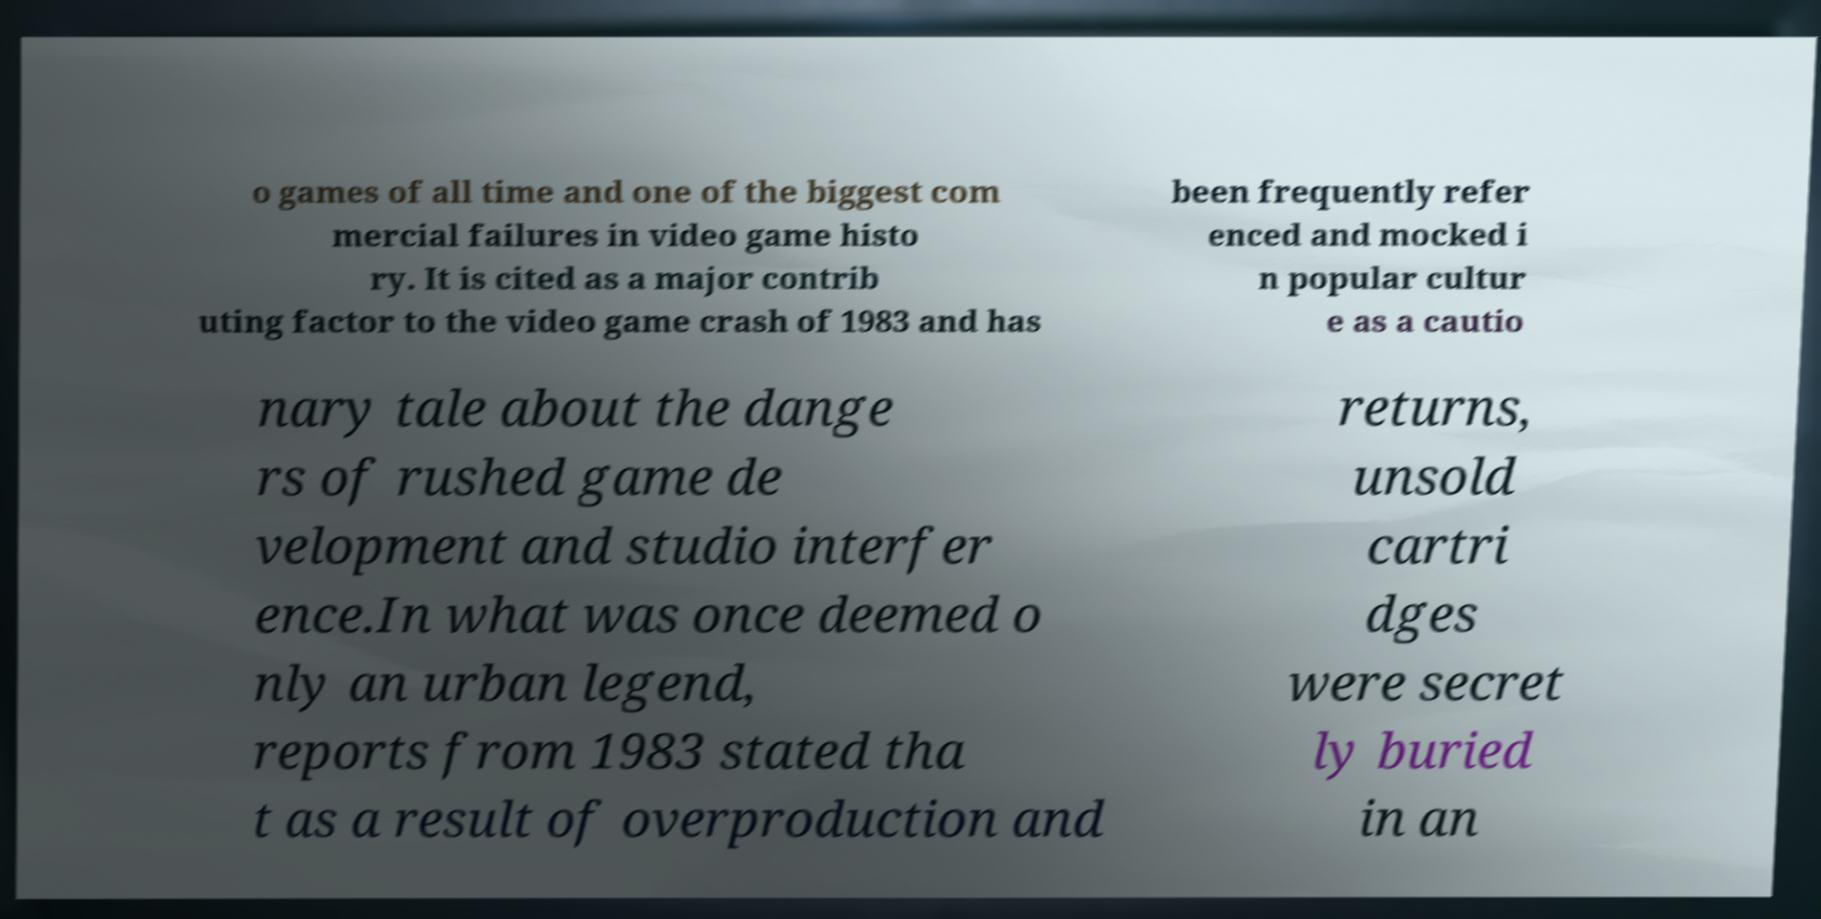There's text embedded in this image that I need extracted. Can you transcribe it verbatim? o games of all time and one of the biggest com mercial failures in video game histo ry. It is cited as a major contrib uting factor to the video game crash of 1983 and has been frequently refer enced and mocked i n popular cultur e as a cautio nary tale about the dange rs of rushed game de velopment and studio interfer ence.In what was once deemed o nly an urban legend, reports from 1983 stated tha t as a result of overproduction and returns, unsold cartri dges were secret ly buried in an 